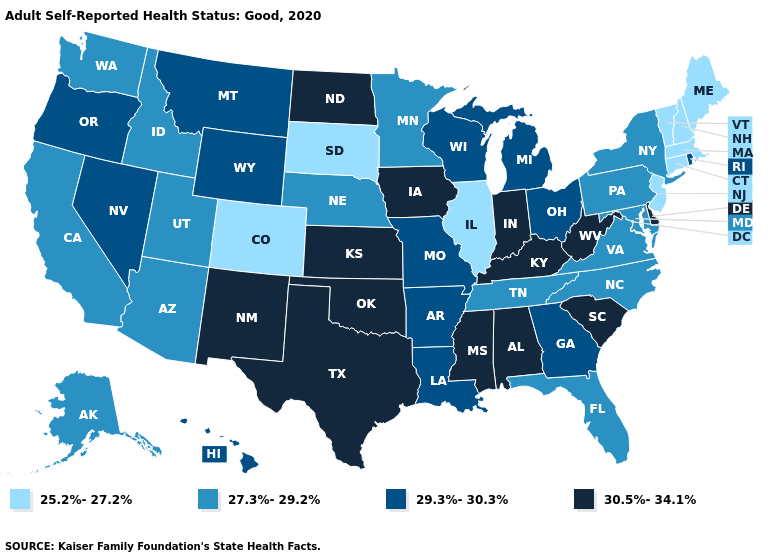Does Colorado have the lowest value in the West?
Concise answer only. Yes. What is the value of Connecticut?
Keep it brief. 25.2%-27.2%. Among the states that border California , which have the lowest value?
Give a very brief answer. Arizona. Among the states that border Idaho , which have the highest value?
Be succinct. Montana, Nevada, Oregon, Wyoming. What is the highest value in the West ?
Short answer required. 30.5%-34.1%. What is the highest value in states that border Vermont?
Answer briefly. 27.3%-29.2%. What is the value of Wyoming?
Quick response, please. 29.3%-30.3%. What is the value of Massachusetts?
Be succinct. 25.2%-27.2%. Which states have the highest value in the USA?
Answer briefly. Alabama, Delaware, Indiana, Iowa, Kansas, Kentucky, Mississippi, New Mexico, North Dakota, Oklahoma, South Carolina, Texas, West Virginia. Name the states that have a value in the range 29.3%-30.3%?
Short answer required. Arkansas, Georgia, Hawaii, Louisiana, Michigan, Missouri, Montana, Nevada, Ohio, Oregon, Rhode Island, Wisconsin, Wyoming. What is the highest value in the MidWest ?
Be succinct. 30.5%-34.1%. Among the states that border New Jersey , which have the lowest value?
Write a very short answer. New York, Pennsylvania. Does Delaware have the lowest value in the South?
Concise answer only. No. What is the value of South Dakota?
Answer briefly. 25.2%-27.2%. Does Maine have the same value as Colorado?
Quick response, please. Yes. 